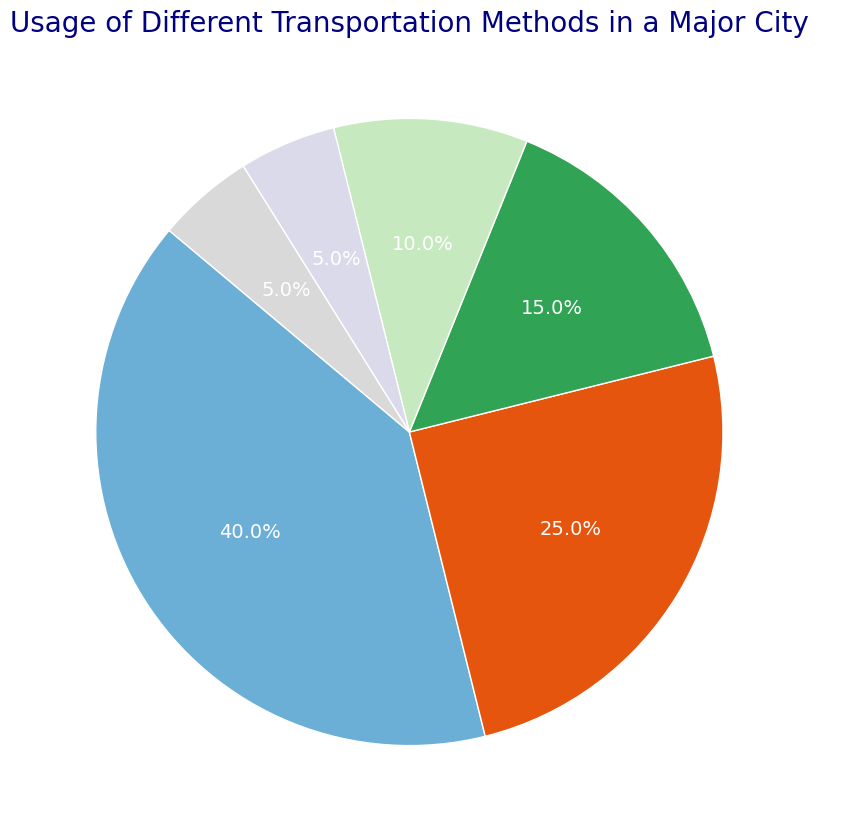What's the most commonly used transportation method in the city? The pie chart shows different transportation methods with their usage percentages. The largest slice represents the most commonly used method.
Answer: Car Which transportation method has the smallest percentage? To find this, look for the smallest slice on the pie chart and check its label.
Answer: Rideshare and Other (both 5%) How much larger is the percentage of Car usage compared to Bicycle usage? First, identify the percentages for Car and Bicycle (40% and 15% respectively). Then subtract Bicycle's percentage from Car's percentage (40% - 15% = 25%).
Answer: 25% Is the combined percentage of Bicycle and Walking usage greater than that of Public Transit? Add the percentages for Bicycle and Walking (15% + 10% = 25%). Compare this result with Public Transit (25%). The combined usage for Bicycle and Walking is equal to that for Public Transit.
Answer: No, it's equal What percentage of transportation methods fall under the category "Public Transit" and "Rideshare" combined? Add the percentages for Public Transit and Rideshare (25% + 5% = 30%).
Answer: 30% How many methods have a usage percentage of more than 20%? Scan the pie chart and count the number of slices with percentages greater than 20%. Only "Car" and "Public Transit" meet this criterion.
Answer: 2 Summing the percentages of Car, Public Transit, and Bicycle, what do you get? Add the percentages of Car, Public Transit, and Bicycle (40% + 25% + 15% = 80%).
Answer: 80% Which transportation methods have an equal percentage, and what is that percentage? Identify the slices with equal sizes and label them. Both "Rideshare" and "Other" have percentages of 5%.
Answer: Rideshare and Other, 5% If Rideshare and Other are combined into one category, what would be their new combined percentage? Add the percentages of Rideshare and Other (5% + 5% = 10%).
Answer: 10% Does the percentage of Walking usage exceed the combined percentage of Rideshare and Other? Compare the percentage for Walking (10%) with the combined percentage of Rideshare and Other (5% + 5% = 10%). Both are equal.
Answer: No, it's equal 